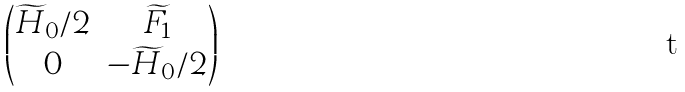<formula> <loc_0><loc_0><loc_500><loc_500>\begin{pmatrix} \widetilde { H } _ { 0 } / 2 & \widetilde { F } _ { 1 } \\ 0 & - \widetilde { H } _ { 0 } / 2 \end{pmatrix}</formula> 